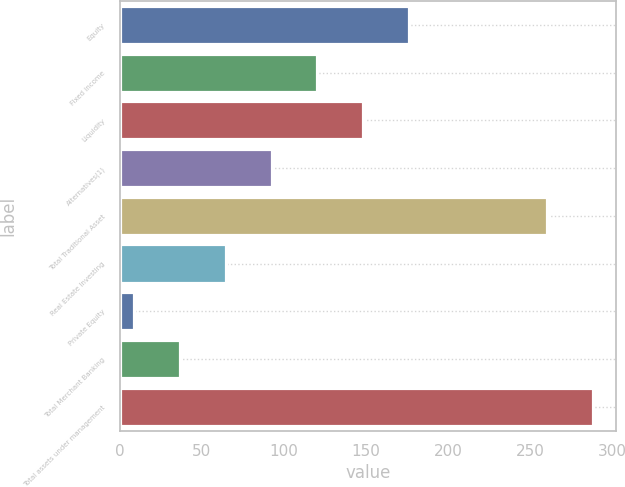<chart> <loc_0><loc_0><loc_500><loc_500><bar_chart><fcel>Equity<fcel>Fixed income<fcel>Liquidity<fcel>Alternatives(1)<fcel>Total Traditional Asset<fcel>Real Estate Investing<fcel>Private Equity<fcel>Total Merchant Banking<fcel>Total assets under management<nl><fcel>175.8<fcel>120.2<fcel>148<fcel>92.4<fcel>260<fcel>64.6<fcel>9<fcel>36.8<fcel>287.8<nl></chart> 